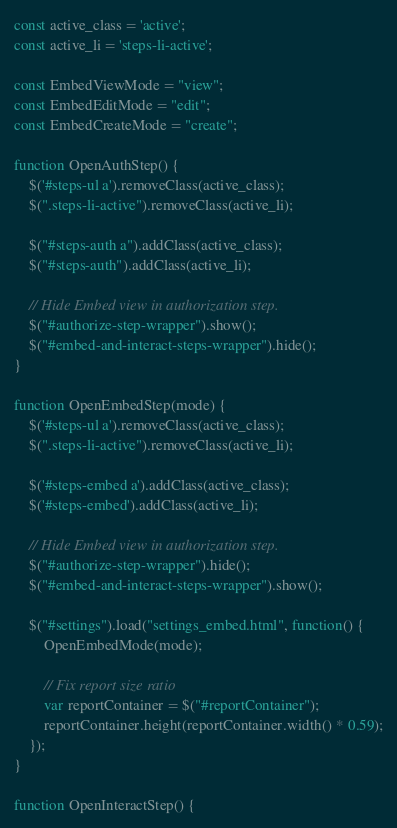<code> <loc_0><loc_0><loc_500><loc_500><_JavaScript_>const active_class = 'active';
const active_li = 'steps-li-active';

const EmbedViewMode = "view";
const EmbedEditMode = "edit";
const EmbedCreateMode = "create";

function OpenAuthStep() {
    $('#steps-ul a').removeClass(active_class);
    $(".steps-li-active").removeClass(active_li);

    $("#steps-auth a").addClass(active_class);
    $("#steps-auth").addClass(active_li);

    // Hide Embed view in authorization step.
    $("#authorize-step-wrapper").show();
    $("#embed-and-interact-steps-wrapper").hide();
}

function OpenEmbedStep(mode) {
    $('#steps-ul a').removeClass(active_class);
    $(".steps-li-active").removeClass(active_li);

    $('#steps-embed a').addClass(active_class);
    $('#steps-embed').addClass(active_li);

    // Hide Embed view in authorization step.
    $("#authorize-step-wrapper").hide();
    $("#embed-and-interact-steps-wrapper").show();

    $("#settings").load("settings_embed.html", function() {
        OpenEmbedMode(mode);

        // Fix report size ratio
        var reportContainer = $("#reportContainer");
        reportContainer.height(reportContainer.width() * 0.59);
    });
}

function OpenInteractStep() {</code> 